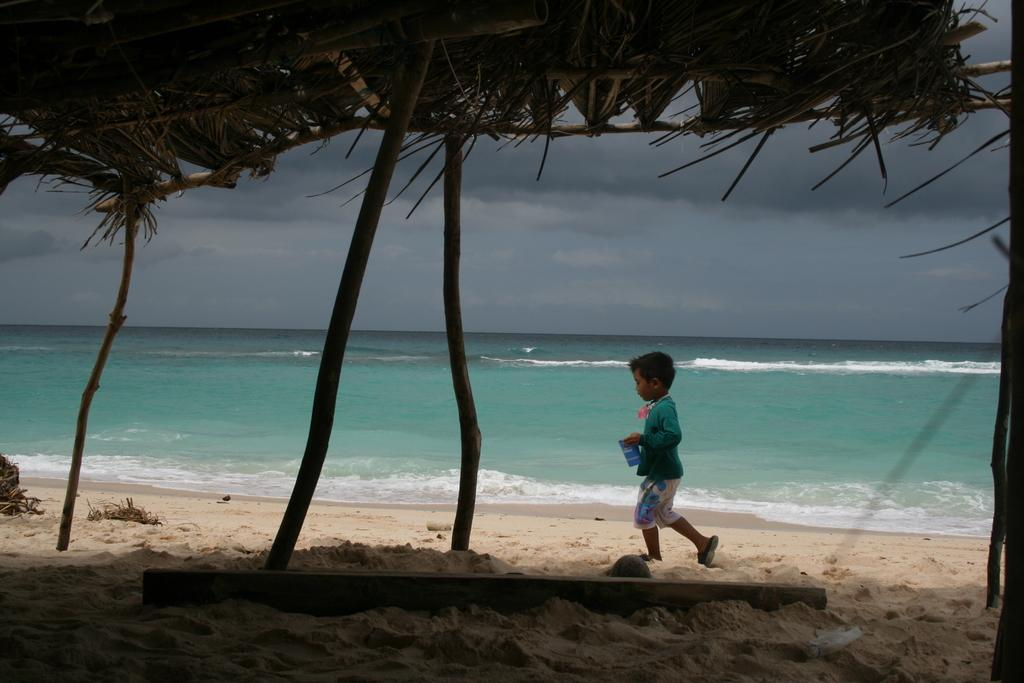What is the main subject of the image? There is a kid in the image. What is the kid doing in the image? The kid is walking in the sand. What natural feature can be seen in the background of the image? There is an ocean visible in the image. What type of terrain is present in the image? There is sand in the image. What object can be seen on the sand? There is a wooden stick on the sand. What type of structure is visible at the top of the image? There is a hut visible at the top of the image. How does the wind affect the sink in the image? There is no sink present in the image, so the wind's effect on a sink cannot be determined. 